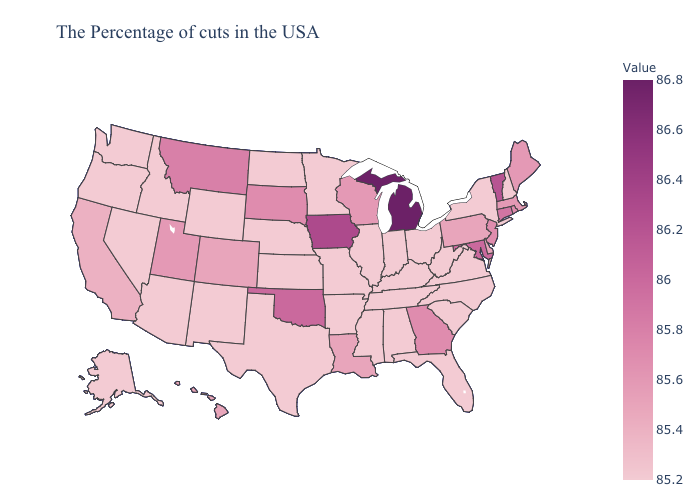Does Vermont have the lowest value in the USA?
Be succinct. No. Is the legend a continuous bar?
Give a very brief answer. Yes. Does Maryland have the lowest value in the South?
Answer briefly. No. Among the states that border Florida , does Alabama have the lowest value?
Keep it brief. Yes. Does Michigan have the highest value in the USA?
Answer briefly. Yes. 